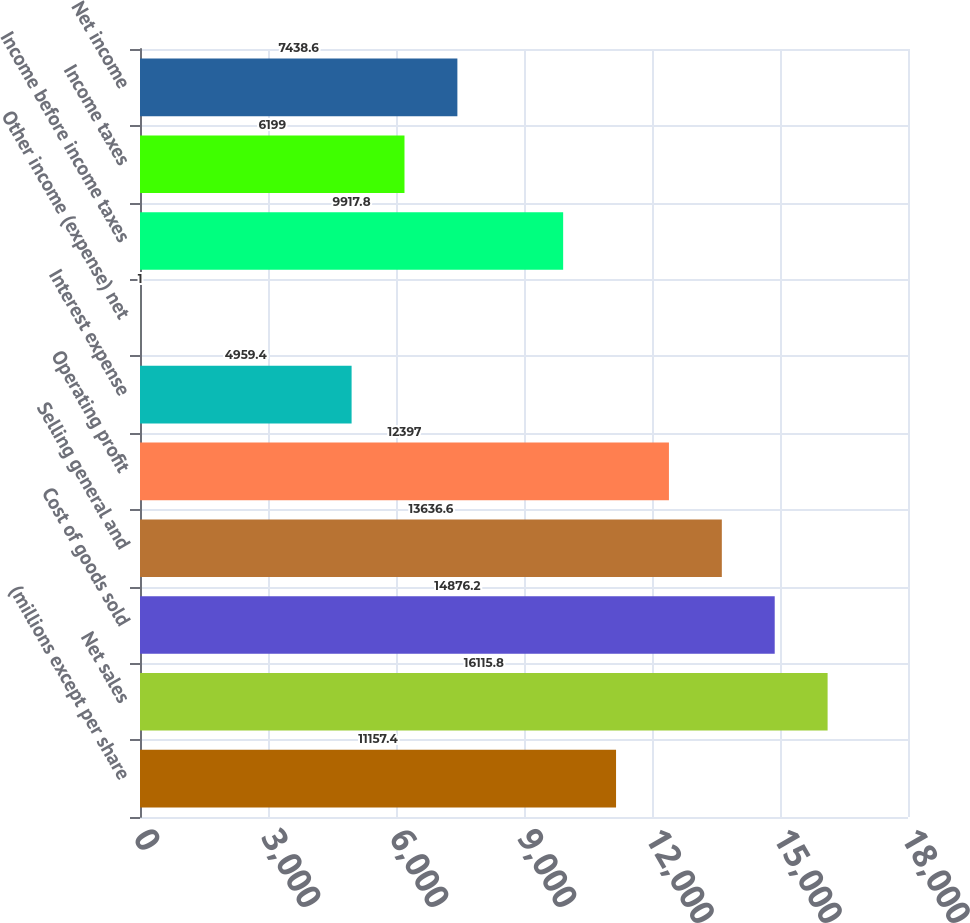<chart> <loc_0><loc_0><loc_500><loc_500><bar_chart><fcel>(millions except per share<fcel>Net sales<fcel>Cost of goods sold<fcel>Selling general and<fcel>Operating profit<fcel>Interest expense<fcel>Other income (expense) net<fcel>Income before income taxes<fcel>Income taxes<fcel>Net income<nl><fcel>11157.4<fcel>16115.8<fcel>14876.2<fcel>13636.6<fcel>12397<fcel>4959.4<fcel>1<fcel>9917.8<fcel>6199<fcel>7438.6<nl></chart> 